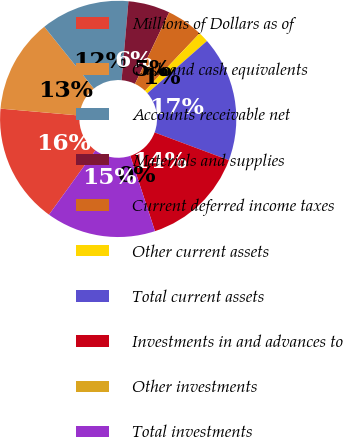Convert chart. <chart><loc_0><loc_0><loc_500><loc_500><pie_chart><fcel>Millions of Dollars as of<fcel>Cash and cash equivalents<fcel>Accounts receivable net<fcel>Materials and supplies<fcel>Current deferred income taxes<fcel>Other current assets<fcel>Total current assets<fcel>Investments in and advances to<fcel>Other investments<fcel>Total investments<nl><fcel>16.43%<fcel>12.86%<fcel>12.14%<fcel>5.72%<fcel>5.0%<fcel>1.43%<fcel>17.14%<fcel>14.28%<fcel>0.0%<fcel>15.0%<nl></chart> 